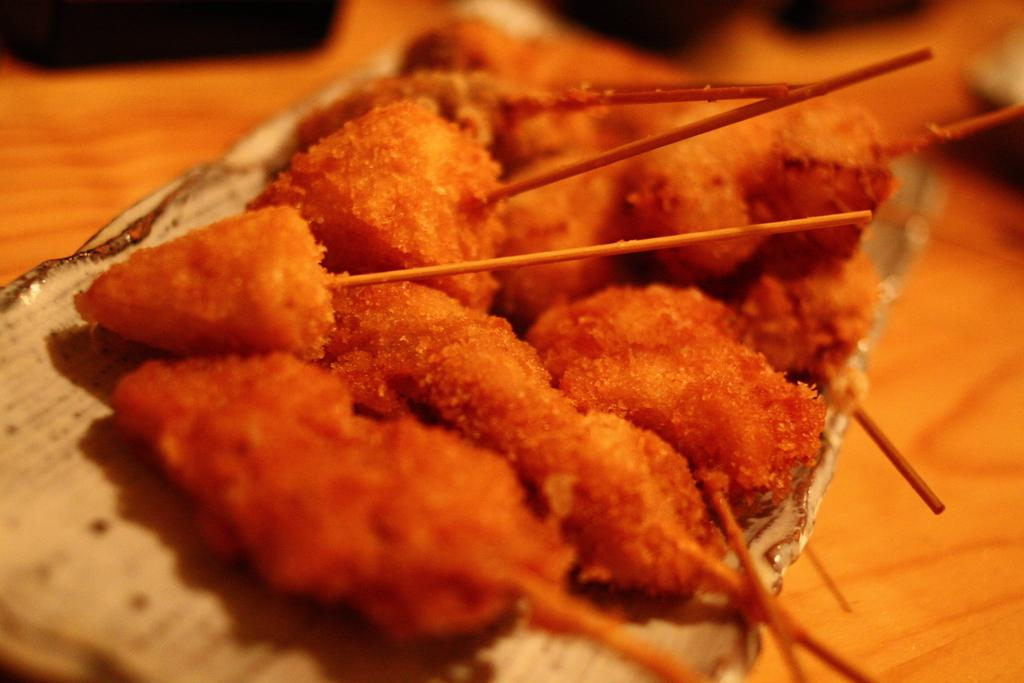What is the color of the food item in the image? The food item has a red color. What is unique about the shape or structure of the food item? The food item has sticks. On what surface is the food item placed? The food item is on a surface. What type of toothbrush is used to clean the food item in the image? There is no toothbrush present in the image, and the food item does not require cleaning. 